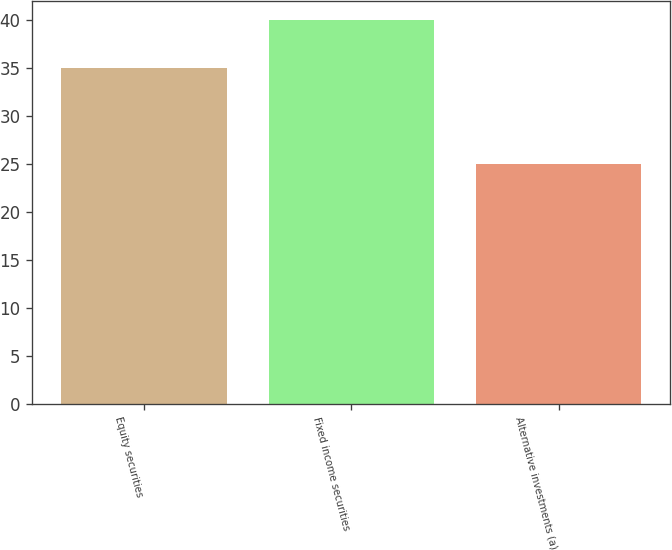<chart> <loc_0><loc_0><loc_500><loc_500><bar_chart><fcel>Equity securities<fcel>Fixed income securities<fcel>Alternative investments (a)<nl><fcel>35<fcel>40<fcel>25<nl></chart> 